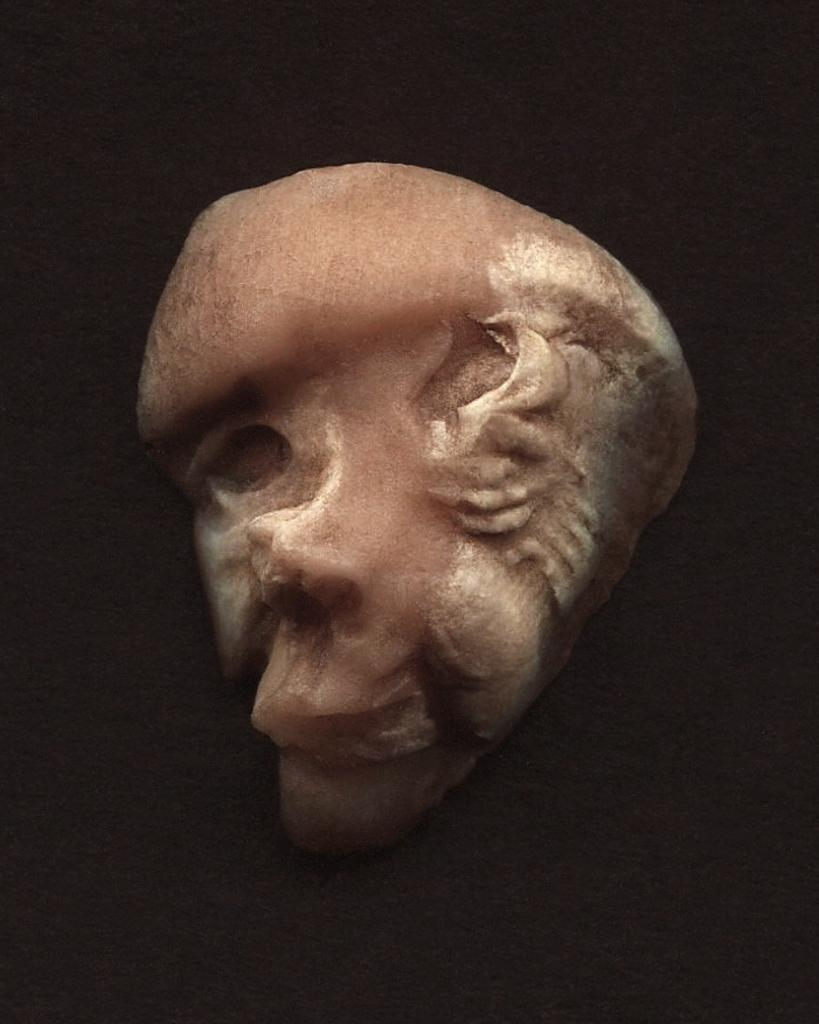What is present on the wall in the image? There is an object on the wall in the image. What type of disgust can be seen on the object on the wall in the image? There is no indication of disgust in the image, as it only features an object on the wall. 